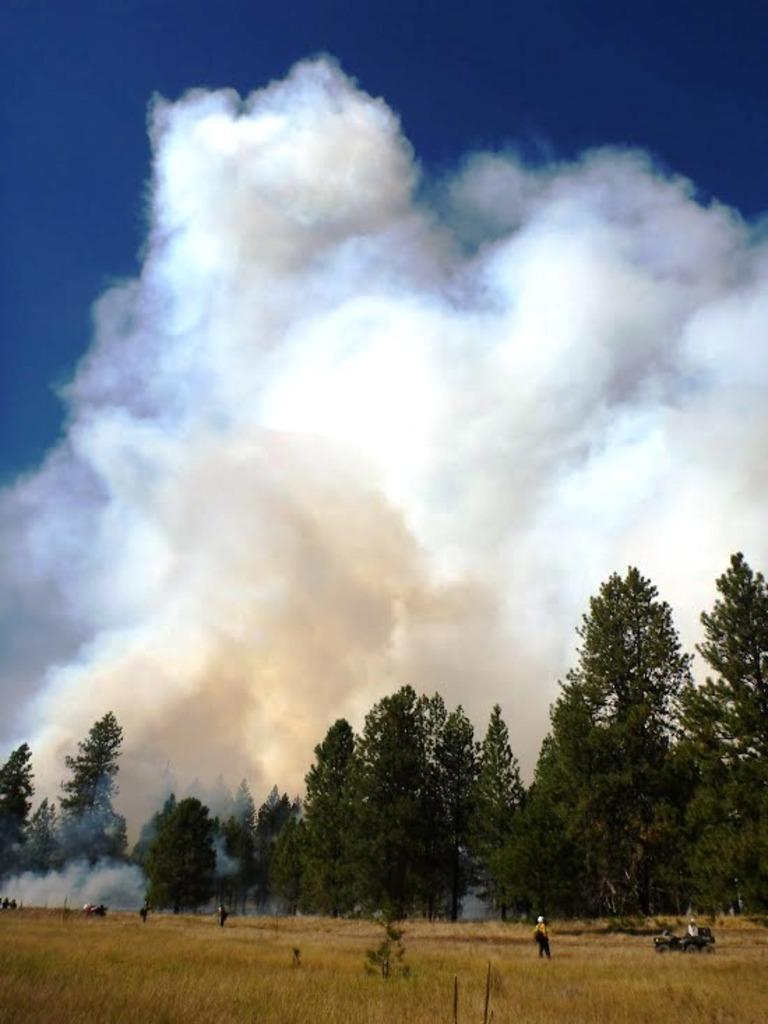What type of landscape is shown in the image? There is a field in the image. Can you describe the person in the image? There is a person in the image. What else can be seen in the image besides the field and person? There is a vehicle, trees in the background, smoke in the background, and the sky is visible in the image. What type of wire is being used by the mice in the image? There are no mice or wire present in the image. What flavor of pickle can be seen in the image? There is no pickle present in the image. 